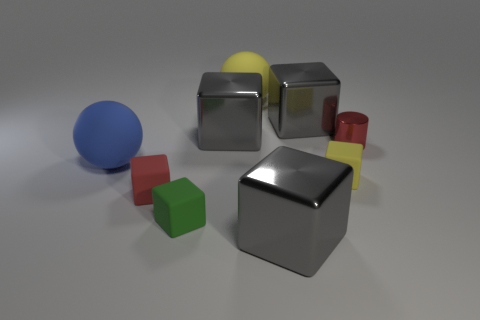Are there any other things that are the same shape as the red metallic object?
Your response must be concise. No. There is a rubber block to the right of the gray shiny object that is in front of the green matte block; what is its color?
Offer a terse response. Yellow. Does the blue rubber thing have the same size as the red matte object?
Give a very brief answer. No. What material is the big yellow thing that is the same shape as the large blue thing?
Keep it short and to the point. Rubber. How many green blocks have the same size as the red cylinder?
Your response must be concise. 1. There is another sphere that is made of the same material as the large blue ball; what is its color?
Provide a short and direct response. Yellow. Is the number of large yellow rubber things less than the number of tiny cyan objects?
Give a very brief answer. No. How many blue things are metal things or matte spheres?
Offer a terse response. 1. What number of objects are both left of the metal cylinder and to the right of the blue ball?
Your answer should be very brief. 7. Is the green thing made of the same material as the red cylinder?
Your answer should be very brief. No. 